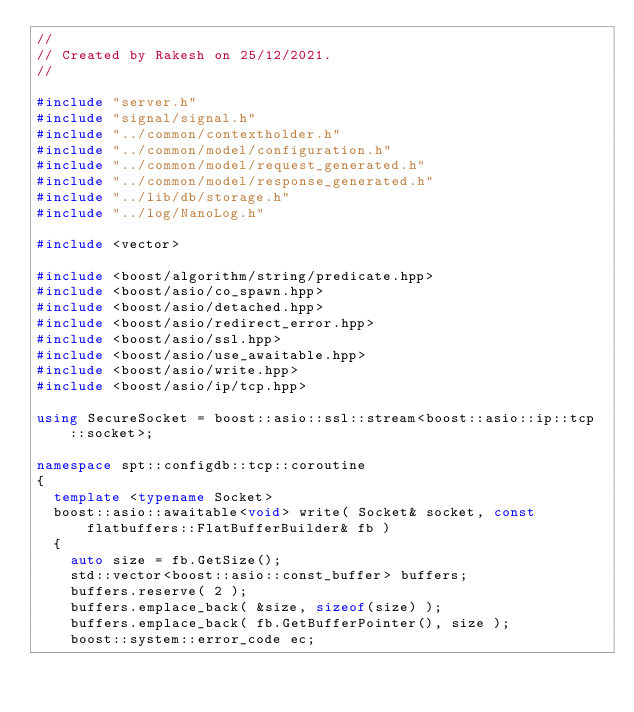Convert code to text. <code><loc_0><loc_0><loc_500><loc_500><_C++_>//
// Created by Rakesh on 25/12/2021.
//

#include "server.h"
#include "signal/signal.h"
#include "../common/contextholder.h"
#include "../common/model/configuration.h"
#include "../common/model/request_generated.h"
#include "../common/model/response_generated.h"
#include "../lib/db/storage.h"
#include "../log/NanoLog.h"

#include <vector>

#include <boost/algorithm/string/predicate.hpp>
#include <boost/asio/co_spawn.hpp>
#include <boost/asio/detached.hpp>
#include <boost/asio/redirect_error.hpp>
#include <boost/asio/ssl.hpp>
#include <boost/asio/use_awaitable.hpp>
#include <boost/asio/write.hpp>
#include <boost/asio/ip/tcp.hpp>

using SecureSocket = boost::asio::ssl::stream<boost::asio::ip::tcp::socket>;

namespace spt::configdb::tcp::coroutine
{
  template <typename Socket>
  boost::asio::awaitable<void> write( Socket& socket, const flatbuffers::FlatBufferBuilder& fb )
  {
    auto size = fb.GetSize();
    std::vector<boost::asio::const_buffer> buffers;
    buffers.reserve( 2 );
    buffers.emplace_back( &size, sizeof(size) );
    buffers.emplace_back( fb.GetBufferPointer(), size );
    boost::system::error_code ec;</code> 